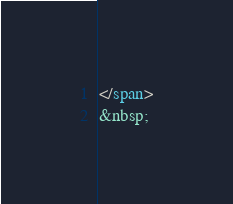Convert code to text. <code><loc_0><loc_0><loc_500><loc_500><_HTML_></span>
&nbsp;
</code> 